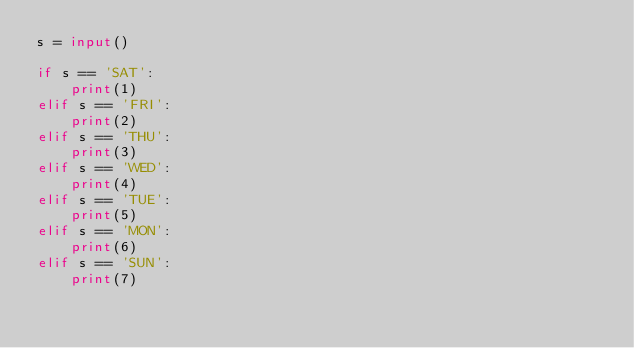Convert code to text. <code><loc_0><loc_0><loc_500><loc_500><_Python_>s = input()

if s == 'SAT':
    print(1)
elif s == 'FRI':
    print(2)
elif s == 'THU':
    print(3)
elif s == 'WED':
    print(4)
elif s == 'TUE':
    print(5)
elif s == 'MON':
    print(6)
elif s == 'SUN':
    print(7)</code> 